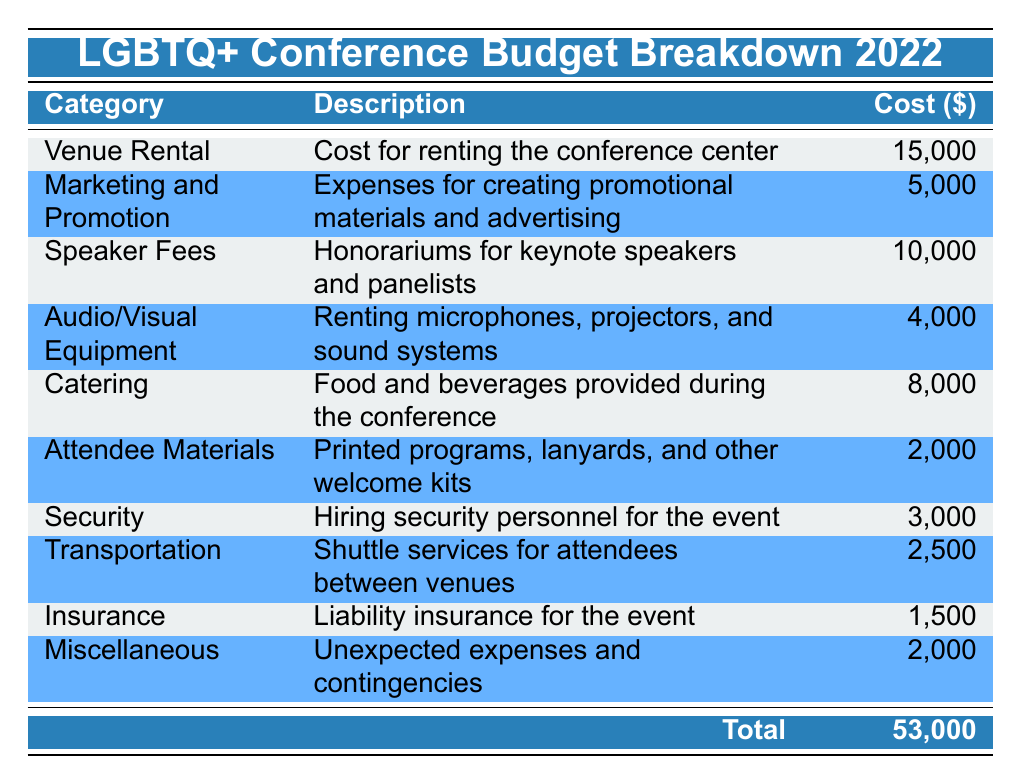What is the cost of the Venue Rental category? The table shows that the cost for "Venue Rental" is listed directly under the "Cost" column as 15,000.
Answer: 15,000 What is the total cost for Marketing and Promotion, and Security? The cost for "Marketing and Promotion" is 5,000 and for "Security" it is 3,000. Adding these two amounts gives 5,000 + 3,000 = 8,000.
Answer: 8,000 Is the cost of Audio/Visual Equipment greater than the cost of Insurance? The cost for "Audio/Visual Equipment" is listed as 4,000, while the cost for "Insurance" is 1,500. Since 4,000 is greater than 1,500, the answer is yes.
Answer: Yes What percentage of the total budget does Catering represent? The total budget is 53,000 and the cost for "Catering" is 8,000. To find the percentage, divide 8,000 by 53,000 and multiply by 100, which results in approximately 15.09%.
Answer: 15.09% How much more was spent on Speaker Fees compared to Security? The cost for "Speaker Fees" is 10,000 and for "Security" it is 3,000. Subtracting these gives 10,000 - 3,000 = 7,000 indicating that 7,000 more was spent on Speaker Fees.
Answer: 7,000 What is the cost difference between Catering and Attendee Materials? "Catering" costs 8,000, while "Attendee Materials" cost 2,000. To find the difference, subtract 2,000 from 8,000, resulting in 8,000 - 2,000 = 6,000.
Answer: 6,000 Is the total of Miscellaneous and Insurance costs equal to the cost of Transportation? The combined cost of "Miscellaneous" (2,000) and "Insurance" (1,500) is 2,000 + 1,500 = 3,500, while "Transportation" costs 2,500. Since 3,500 does not equal 2,500, the answer is no.
Answer: No Identify the category with the lowest expense. By reviewing the "Cost" column, "Insurance" has the lowest expense listed at 1,500, making it the category with the least cost.
Answer: Insurance What is the total spent on the top three expense categories? The top three categories by expense are "Venue Rental" (15,000), "Speaker Fees" (10,000), and "Catering" (8,000). Summing these gives 15,000 + 10,000 + 8,000 = 33,000 for the top three expenses.
Answer: 33,000 